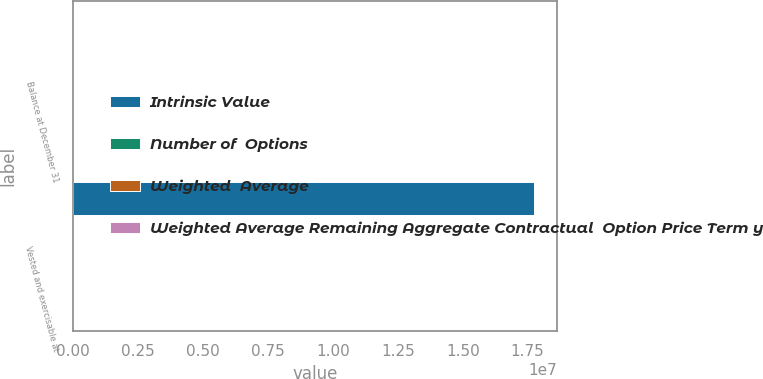<chart> <loc_0><loc_0><loc_500><loc_500><stacked_bar_chart><ecel><fcel>Balance at December 31<fcel>Vested and exercisable at<nl><fcel>Intrinsic Value<fcel>37.4<fcel>1.77318e+07<nl><fcel>Number of  Options<fcel>37.4<fcel>34.41<nl><fcel>Weighted  Average<fcel>6.4<fcel>5.3<nl><fcel>Weighted Average Remaining Aggregate Contractual  Option Price Term years<fcel>102<fcel>65<nl></chart> 